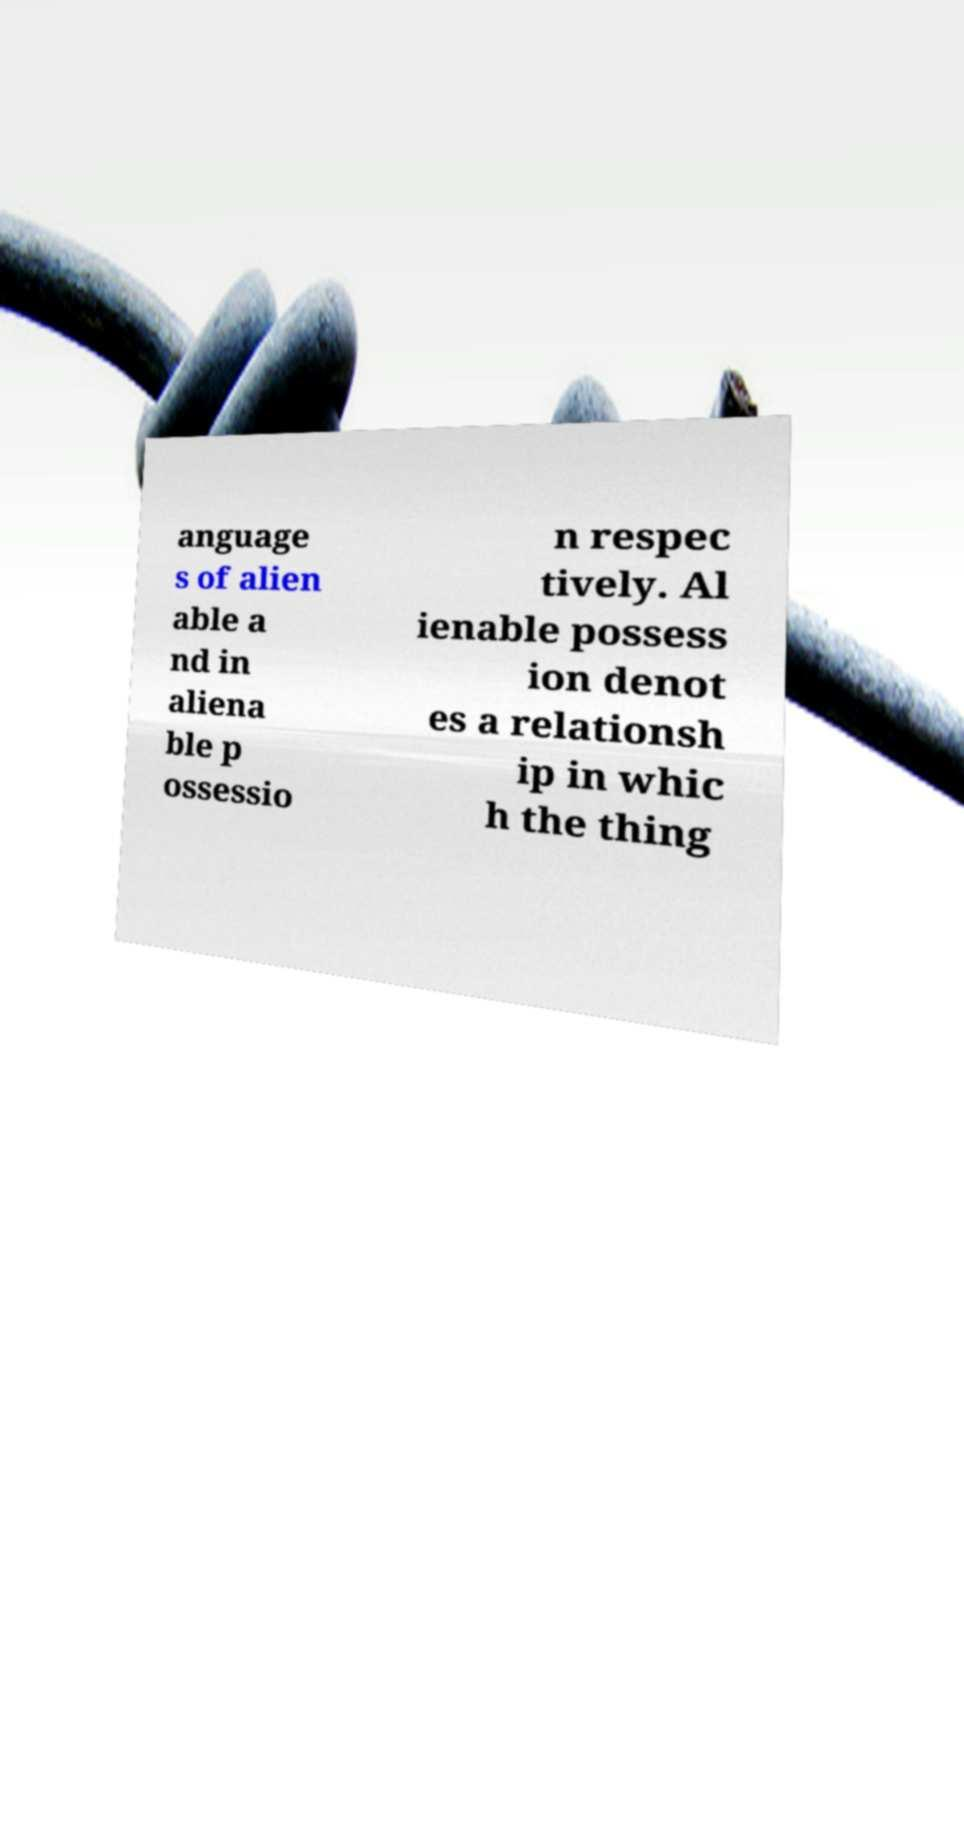Can you accurately transcribe the text from the provided image for me? anguage s of alien able a nd in aliena ble p ossessio n respec tively. Al ienable possess ion denot es a relationsh ip in whic h the thing 